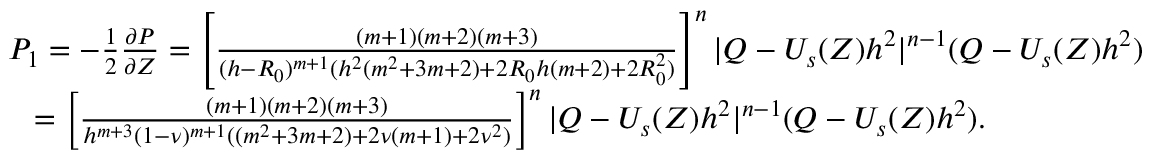Convert formula to latex. <formula><loc_0><loc_0><loc_500><loc_500>\begin{array} { r } { P _ { 1 } = - \frac { 1 } { 2 } \frac { \partial P } { \partial Z } = \left [ \frac { ( m + 1 ) ( m + 2 ) ( m + 3 ) } { ( h - R _ { 0 } ) ^ { m + 1 } ( h ^ { 2 } ( m ^ { 2 } + 3 m + 2 ) + 2 R _ { 0 } h ( m + 2 ) + 2 R _ { 0 } ^ { 2 } ) } \right ] ^ { n } | Q - U _ { s } ( Z ) h ^ { 2 } | ^ { n - 1 } ( Q - U _ { s } ( Z ) h ^ { 2 } ) } \\ { = \left [ \frac { ( m + 1 ) ( m + 2 ) ( m + 3 ) } { h ^ { m + 3 } ( 1 - \nu ) ^ { m + 1 } ( ( m ^ { 2 } + 3 m + 2 ) + 2 \nu ( m + 1 ) + 2 \nu ^ { 2 } ) } \right ] ^ { n } | Q - U _ { s } ( Z ) h ^ { 2 } | ^ { n - 1 } ( Q - U _ { s } ( Z ) h ^ { 2 } ) . } \end{array}</formula> 